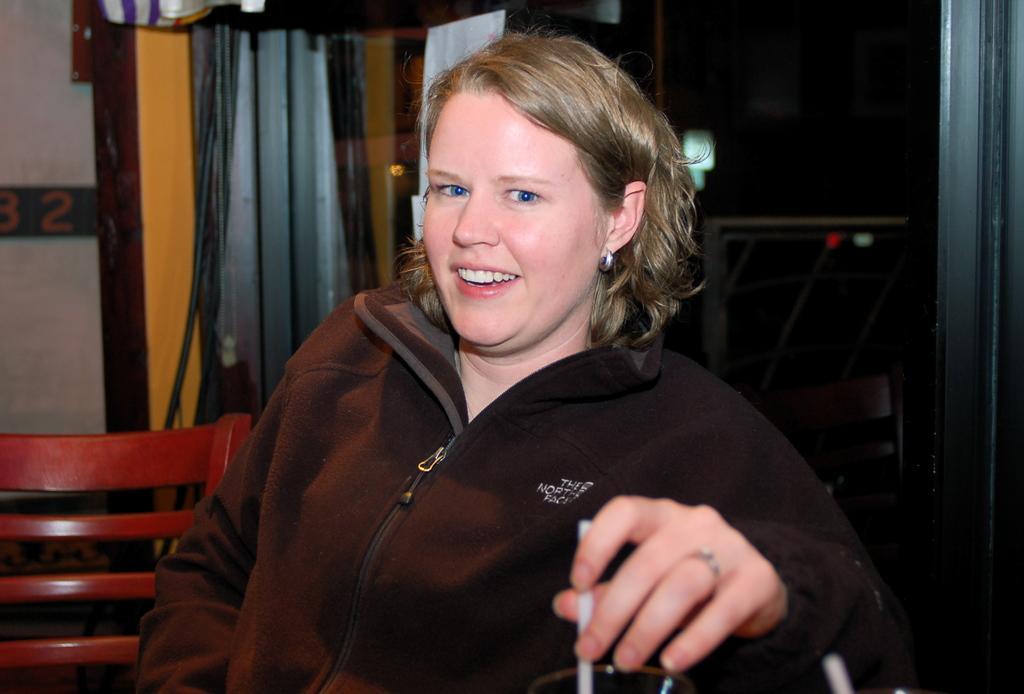Please provide a concise description of this image. In this image we can see a lady person wearing black color dress sitting on chair holding straw in her hands and in the background of the image there are cupboards, curtains and there is a wall. 